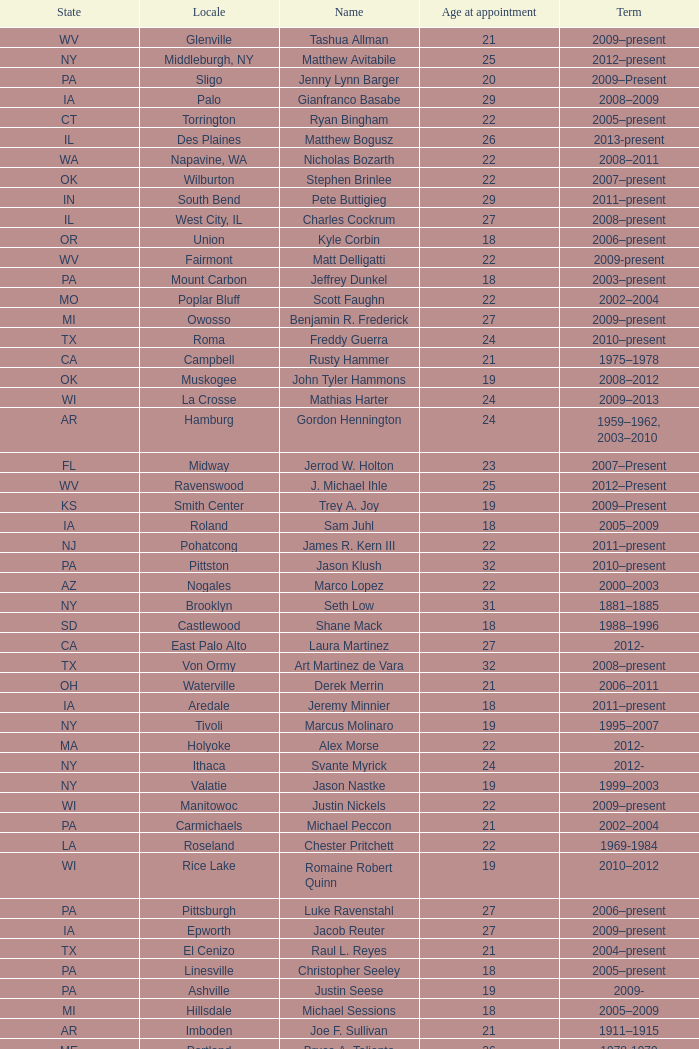Help me parse the entirety of this table. {'header': ['State', 'Locale', 'Name', 'Age at appointment', 'Term'], 'rows': [['WV', 'Glenville', 'Tashua Allman', '21', '2009–present'], ['NY', 'Middleburgh, NY', 'Matthew Avitabile', '25', '2012–present'], ['PA', 'Sligo', 'Jenny Lynn Barger', '20', '2009–Present'], ['IA', 'Palo', 'Gianfranco Basabe', '29', '2008–2009'], ['CT', 'Torrington', 'Ryan Bingham', '22', '2005–present'], ['IL', 'Des Plaines', 'Matthew Bogusz', '26', '2013-present'], ['WA', 'Napavine, WA', 'Nicholas Bozarth', '22', '2008–2011'], ['OK', 'Wilburton', 'Stephen Brinlee', '22', '2007–present'], ['IN', 'South Bend', 'Pete Buttigieg', '29', '2011–present'], ['IL', 'West City, IL', 'Charles Cockrum', '27', '2008–present'], ['OR', 'Union', 'Kyle Corbin', '18', '2006–present'], ['WV', 'Fairmont', 'Matt Delligatti', '22', '2009-present'], ['PA', 'Mount Carbon', 'Jeffrey Dunkel', '18', '2003–present'], ['MO', 'Poplar Bluff', 'Scott Faughn', '22', '2002–2004'], ['MI', 'Owosso', 'Benjamin R. Frederick', '27', '2009–present'], ['TX', 'Roma', 'Freddy Guerra', '24', '2010–present'], ['CA', 'Campbell', 'Rusty Hammer', '21', '1975–1978'], ['OK', 'Muskogee', 'John Tyler Hammons', '19', '2008–2012'], ['WI', 'La Crosse', 'Mathias Harter', '24', '2009–2013'], ['AR', 'Hamburg', 'Gordon Hennington', '24', '1959–1962, 2003–2010'], ['FL', 'Midway', 'Jerrod W. Holton', '23', '2007–Present'], ['WV', 'Ravenswood', 'J. Michael Ihle', '25', '2012–Present'], ['KS', 'Smith Center', 'Trey A. Joy', '19', '2009–Present'], ['IA', 'Roland', 'Sam Juhl', '18', '2005–2009'], ['NJ', 'Pohatcong', 'James R. Kern III', '22', '2011–present'], ['PA', 'Pittston', 'Jason Klush', '32', '2010–present'], ['AZ', 'Nogales', 'Marco Lopez', '22', '2000–2003'], ['NY', 'Brooklyn', 'Seth Low', '31', '1881–1885'], ['SD', 'Castlewood', 'Shane Mack', '18', '1988–1996'], ['CA', 'East Palo Alto', 'Laura Martinez', '27', '2012-'], ['TX', 'Von Ormy', 'Art Martinez de Vara', '32', '2008–present'], ['OH', 'Waterville', 'Derek Merrin', '21', '2006–2011'], ['IA', 'Aredale', 'Jeremy Minnier', '18', '2011–present'], ['NY', 'Tivoli', 'Marcus Molinaro', '19', '1995–2007'], ['MA', 'Holyoke', 'Alex Morse', '22', '2012-'], ['NY', 'Ithaca', 'Svante Myrick', '24', '2012-'], ['NY', 'Valatie', 'Jason Nastke', '19', '1999–2003'], ['WI', 'Manitowoc', 'Justin Nickels', '22', '2009–present'], ['PA', 'Carmichaels', 'Michael Peccon', '21', '2002–2004'], ['LA', 'Roseland', 'Chester Pritchett', '22', '1969-1984'], ['WI', 'Rice Lake', 'Romaine Robert Quinn', '19', '2010–2012'], ['PA', 'Pittsburgh', 'Luke Ravenstahl', '27', '2006–present'], ['IA', 'Epworth', 'Jacob Reuter', '27', '2009–present'], ['TX', 'El Cenizo', 'Raul L. Reyes', '21', '2004–present'], ['PA', 'Linesville', 'Christopher Seeley', '18', '2005–present'], ['PA', 'Ashville', 'Justin Seese', '19', '2009-'], ['MI', 'Hillsdale', 'Michael Sessions', '18', '2005–2009'], ['AR', 'Imboden', 'Joe F. Sullivan', '21', '1911–1915'], ['ME', 'Portland', 'Bruce A. Taliento', '26', '1978-1979'], ['MI', 'Holland', 'Philip A. Tanis', '23', '1987-1989'], ['AR', 'Van Buren', 'Charles Taylor', '21', '1885-?'], ['TN', 'Mount Juliet', 'Willie Morgan Todd', '21', '2012–present'], ['TX', 'Gun Barrel City, Texas', 'Tye Thomas', '21', '2000-2001'], ['MN', 'Dorset', 'Robert Tufts', '4', '2013'], ['WI', 'Wisconsin Rapids, WI', 'Zachary J. Vruwink', '24', '2012–present'], ['NY', 'New Paltz', 'Jason West', '26', '2003–2007'], ['NC', 'Ellerbe, NC', 'Olivia Webb', '25', '2009–present'], ['TX', 'Blossom, Texas', 'Jeremy Wilson', '24', '2010–present'], ['CA', 'Placentia', 'Jeremy Yamaguchi', '22', '2012–'], ['NJ', 'Alpha', 'Harry Zikas, Jr.', '21', '2000–2007'], ['TX', 'Crabb', 'Brian Zimmerman', '11', '1983 - ?']]} What is the name of the holland locale Philip A. Tanis. 